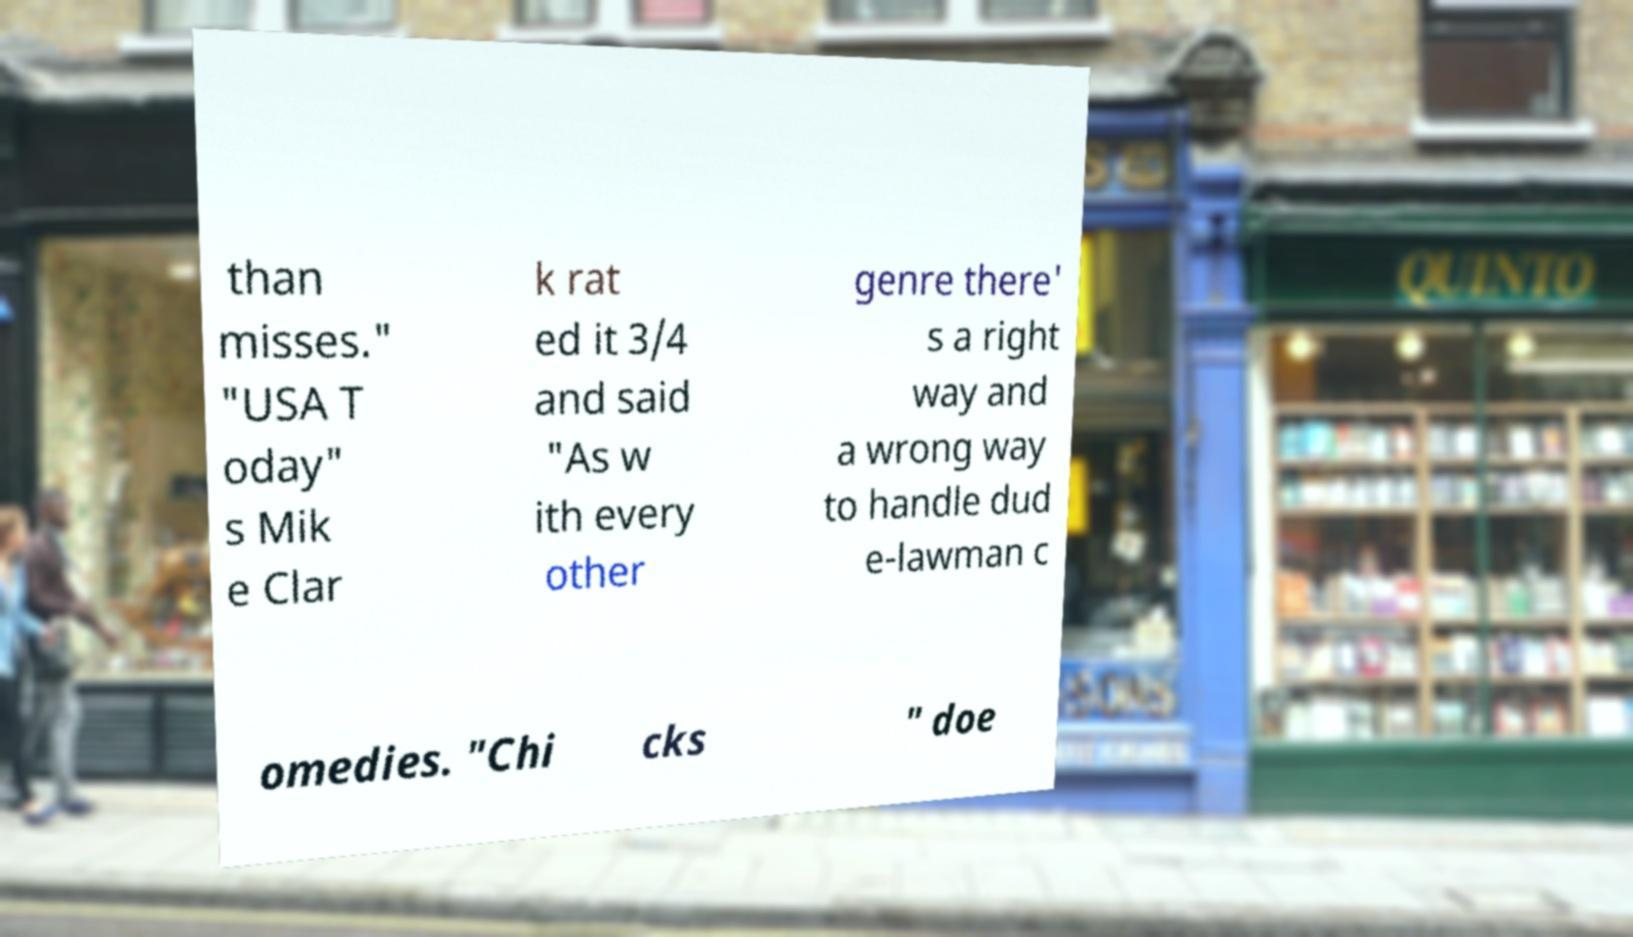Please identify and transcribe the text found in this image. than misses." "USA T oday" s Mik e Clar k rat ed it 3/4 and said "As w ith every other genre there' s a right way and a wrong way to handle dud e-lawman c omedies. "Chi cks " doe 